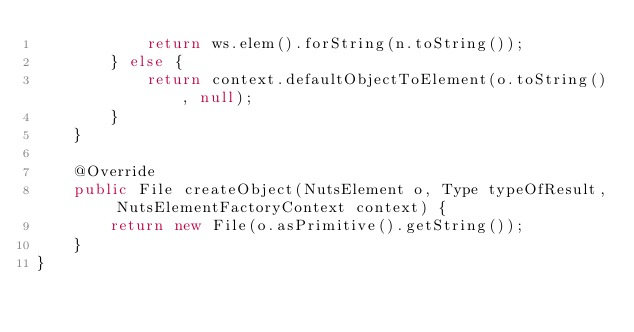Convert code to text. <code><loc_0><loc_0><loc_500><loc_500><_Java_>            return ws.elem().forString(n.toString());
        } else {
            return context.defaultObjectToElement(o.toString(), null);
        }
    }

    @Override
    public File createObject(NutsElement o, Type typeOfResult, NutsElementFactoryContext context) {
        return new File(o.asPrimitive().getString());
    }
}
</code> 